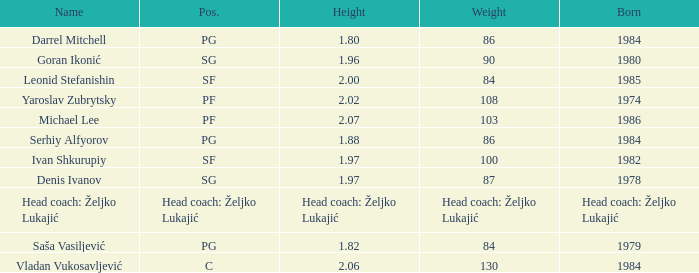Parse the table in full. {'header': ['Name', 'Pos.', 'Height', 'Weight', 'Born'], 'rows': [['Darrel Mitchell', 'PG', '1.80', '86', '1984'], ['Goran Ikonić', 'SG', '1.96', '90', '1980'], ['Leonid Stefanishin', 'SF', '2.00', '84', '1985'], ['Yaroslav Zubrytsky', 'PF', '2.02', '108', '1974'], ['Michael Lee', 'PF', '2.07', '103', '1986'], ['Serhiy Alfyorov', 'PG', '1.88', '86', '1984'], ['Ivan Shkurupiy', 'SF', '1.97', '100', '1982'], ['Denis Ivanov', 'SG', '1.97', '87', '1978'], ['Head coach: Željko Lukajić', 'Head coach: Željko Lukajić', 'Head coach: Željko Lukajić', 'Head coach: Željko Lukajić', 'Head coach: Željko Lukajić'], ['Saša Vasiljević', 'PG', '1.82', '84', '1979'], ['Vladan Vukosavljević', 'C', '2.06', '130', '1984']]} What is the weight of the person born in 1980? 90.0. 